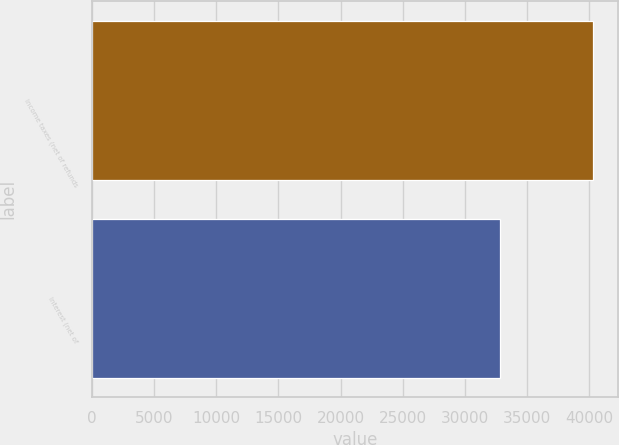Convert chart to OTSL. <chart><loc_0><loc_0><loc_500><loc_500><bar_chart><fcel>Income taxes (net of refunds<fcel>Interest (net of<nl><fcel>40312<fcel>32837<nl></chart> 